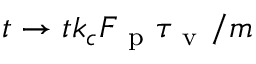<formula> <loc_0><loc_0><loc_500><loc_500>t \rightarrow t k _ { c } F _ { p } \tau _ { v } / m</formula> 